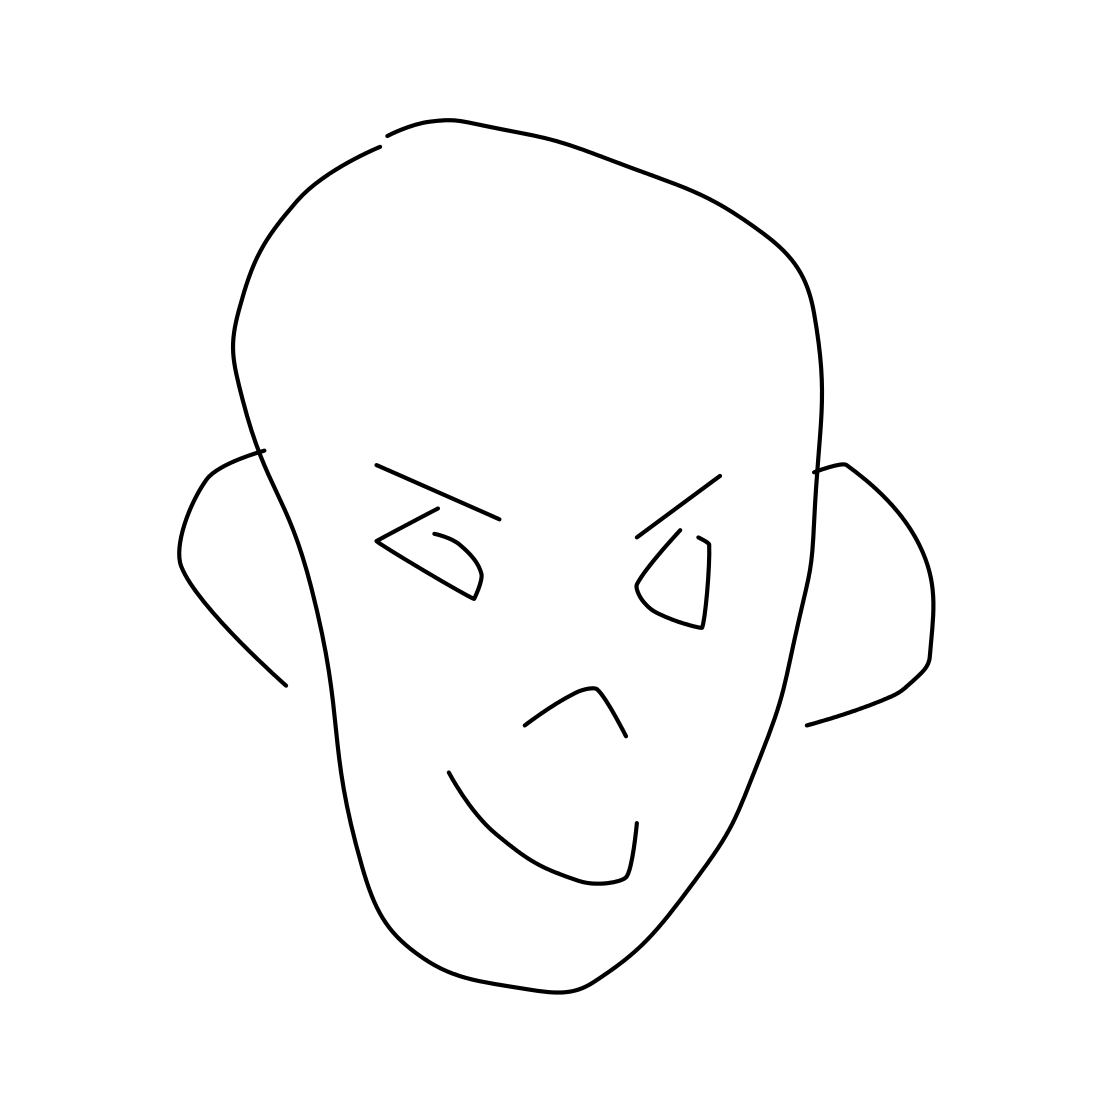Can you describe the style of this drawing? The drawing is minimalist and abstract, utilizing simple lines and geometric shapes to represent the features of a face. It lacks detail and relies on the viewer's interpretation to fill in the details. What emotion does the face seem to express? The facial expression is quite neutral, crafted with minimal lines. The eyes and the slight curve of the mouth suggest a serene or nonchalant demeanor. 